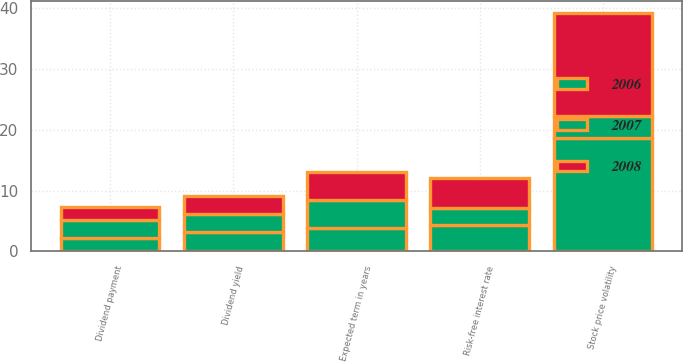<chart> <loc_0><loc_0><loc_500><loc_500><stacked_bar_chart><ecel><fcel>Stock price volatility<fcel>Expected term in years<fcel>Risk-free interest rate<fcel>Dividend yield<fcel>Dividend payment<nl><fcel>2007<fcel>3.55<fcel>4.64<fcel>2.77<fcel>2.96<fcel>3<nl><fcel>2008<fcel>17<fcel>4.59<fcel>4.85<fcel>3<fcel>2.16<nl><fcel>2006<fcel>18.7<fcel>3.9<fcel>4.4<fcel>3.2<fcel>2.16<nl></chart> 